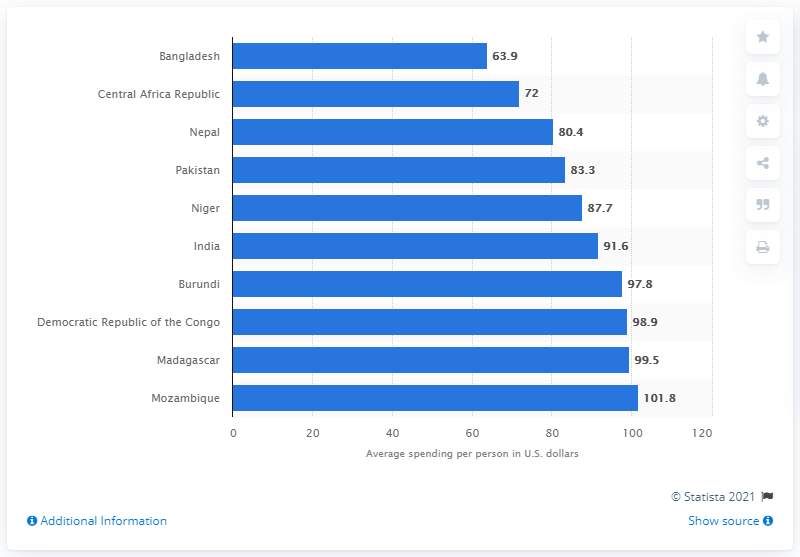List a handful of essential elements in this visual. In 2019, Bangladesh had the lowest diabetes spending per patient among all countries in the world. 